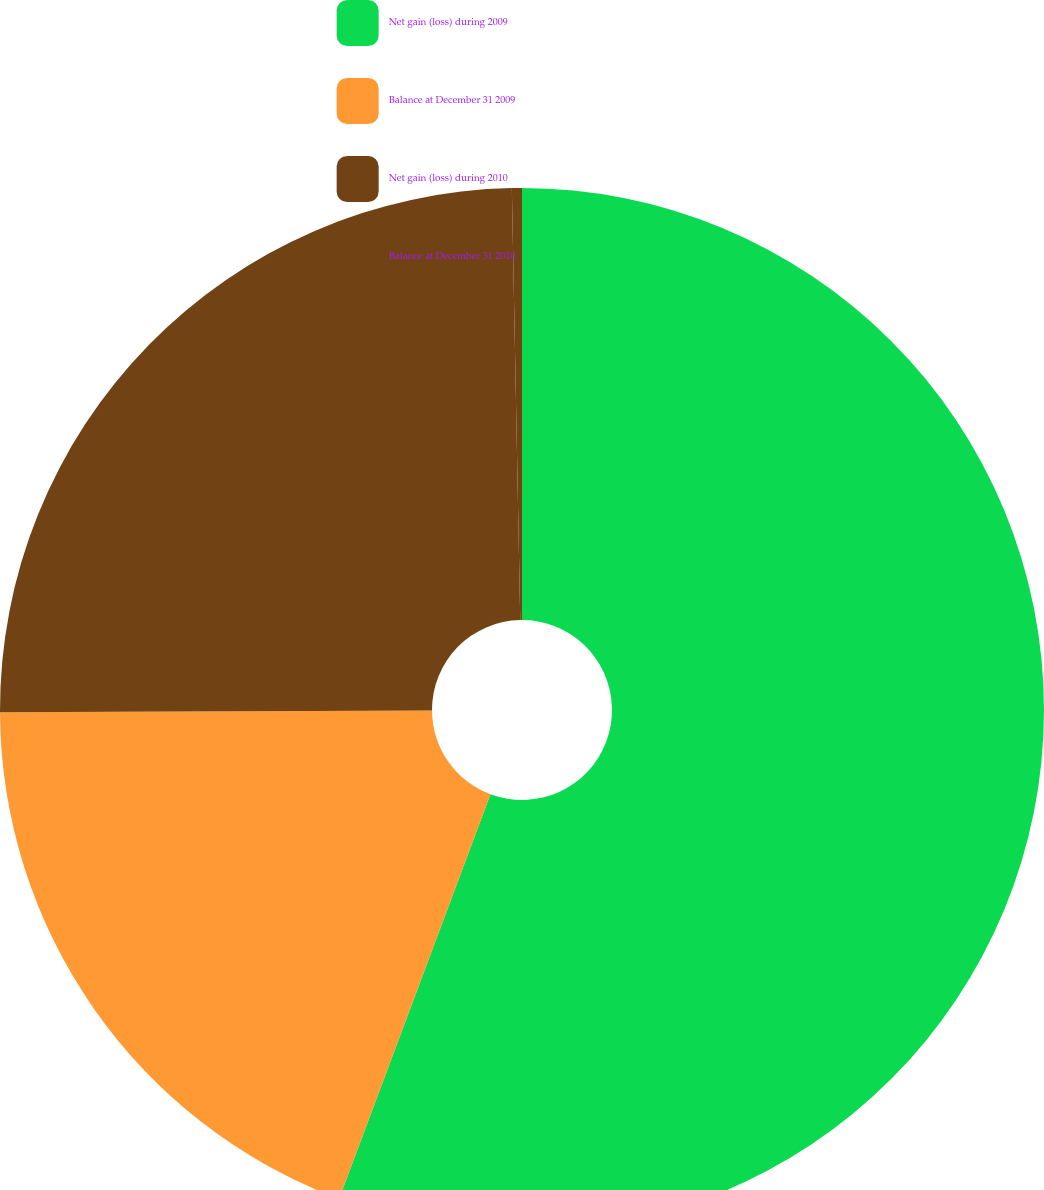<chart> <loc_0><loc_0><loc_500><loc_500><pie_chart><fcel>Net gain (loss) during 2009<fcel>Balance at December 31 2009<fcel>Net gain (loss) during 2010<fcel>Balance at December 31 2010<nl><fcel>55.7%<fcel>19.23%<fcel>24.76%<fcel>0.31%<nl></chart> 